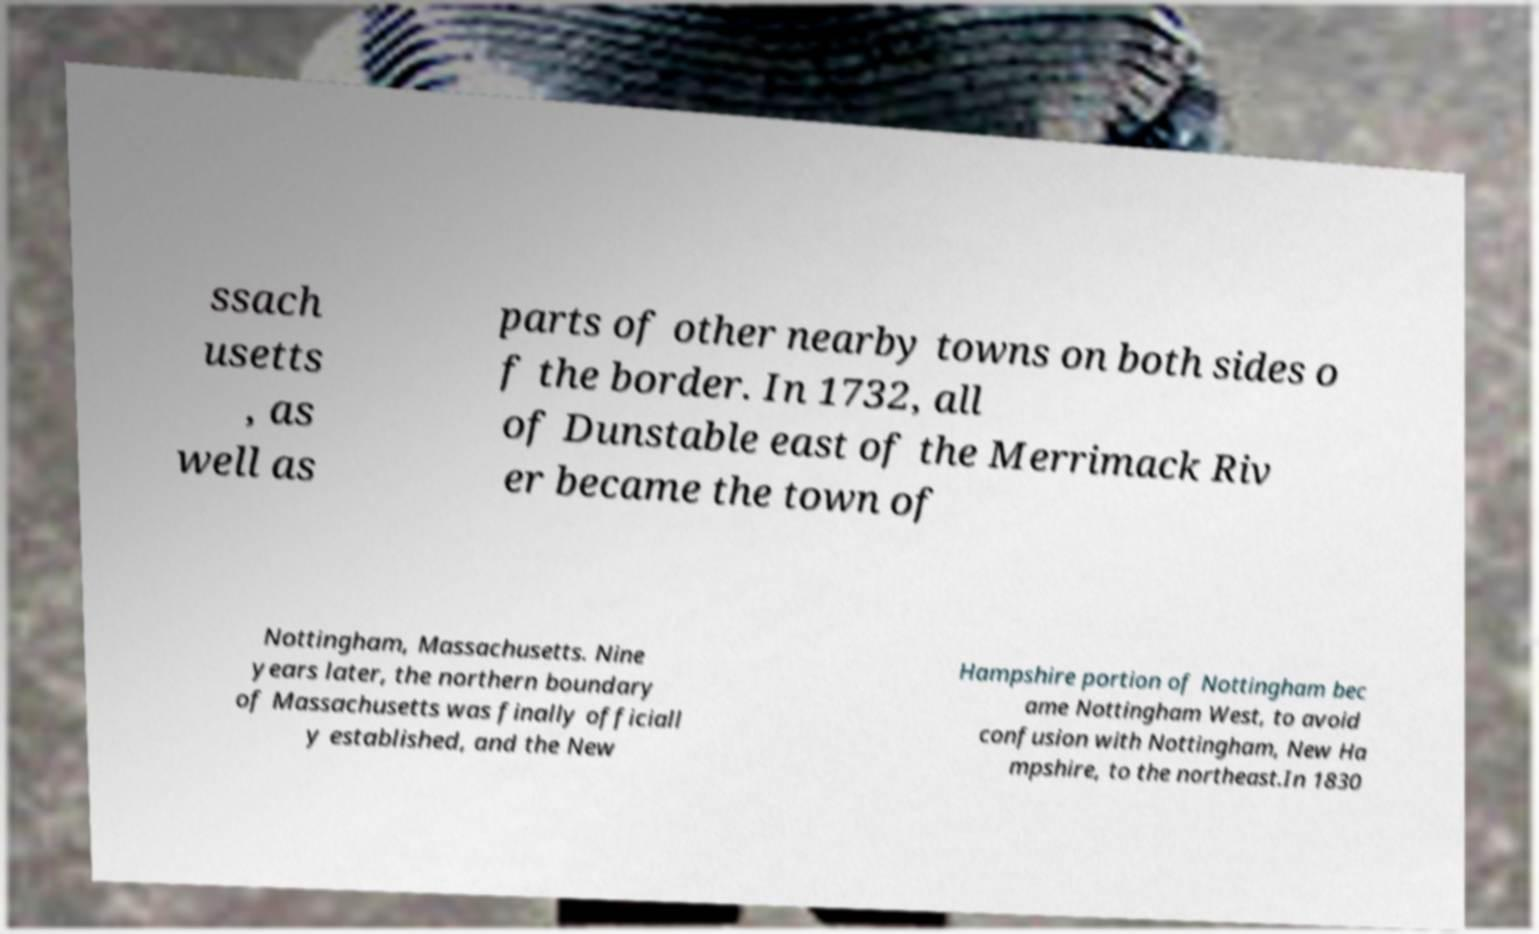What messages or text are displayed in this image? I need them in a readable, typed format. ssach usetts , as well as parts of other nearby towns on both sides o f the border. In 1732, all of Dunstable east of the Merrimack Riv er became the town of Nottingham, Massachusetts. Nine years later, the northern boundary of Massachusetts was finally officiall y established, and the New Hampshire portion of Nottingham bec ame Nottingham West, to avoid confusion with Nottingham, New Ha mpshire, to the northeast.In 1830 